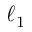Convert formula to latex. <formula><loc_0><loc_0><loc_500><loc_500>\ell _ { 1 }</formula> 